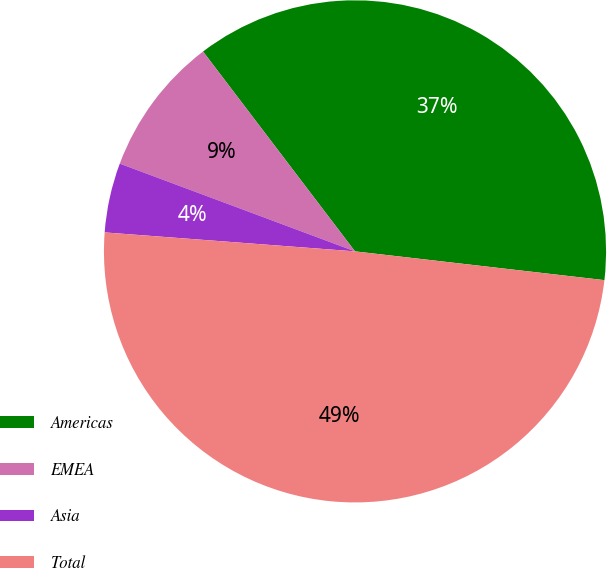Convert chart to OTSL. <chart><loc_0><loc_0><loc_500><loc_500><pie_chart><fcel>Americas<fcel>EMEA<fcel>Asia<fcel>Total<nl><fcel>37.18%<fcel>8.97%<fcel>4.48%<fcel>49.38%<nl></chart> 